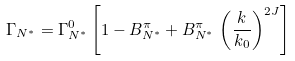Convert formula to latex. <formula><loc_0><loc_0><loc_500><loc_500>\Gamma _ { N ^ { * } } = \Gamma ^ { 0 } _ { N ^ { * } } \left [ 1 - B ^ { \pi } _ { N ^ { * } } + B ^ { \pi } _ { N ^ { * } } \, \left ( \frac { k } { { k } _ { 0 } } \right ) ^ { 2 J } \right ]</formula> 